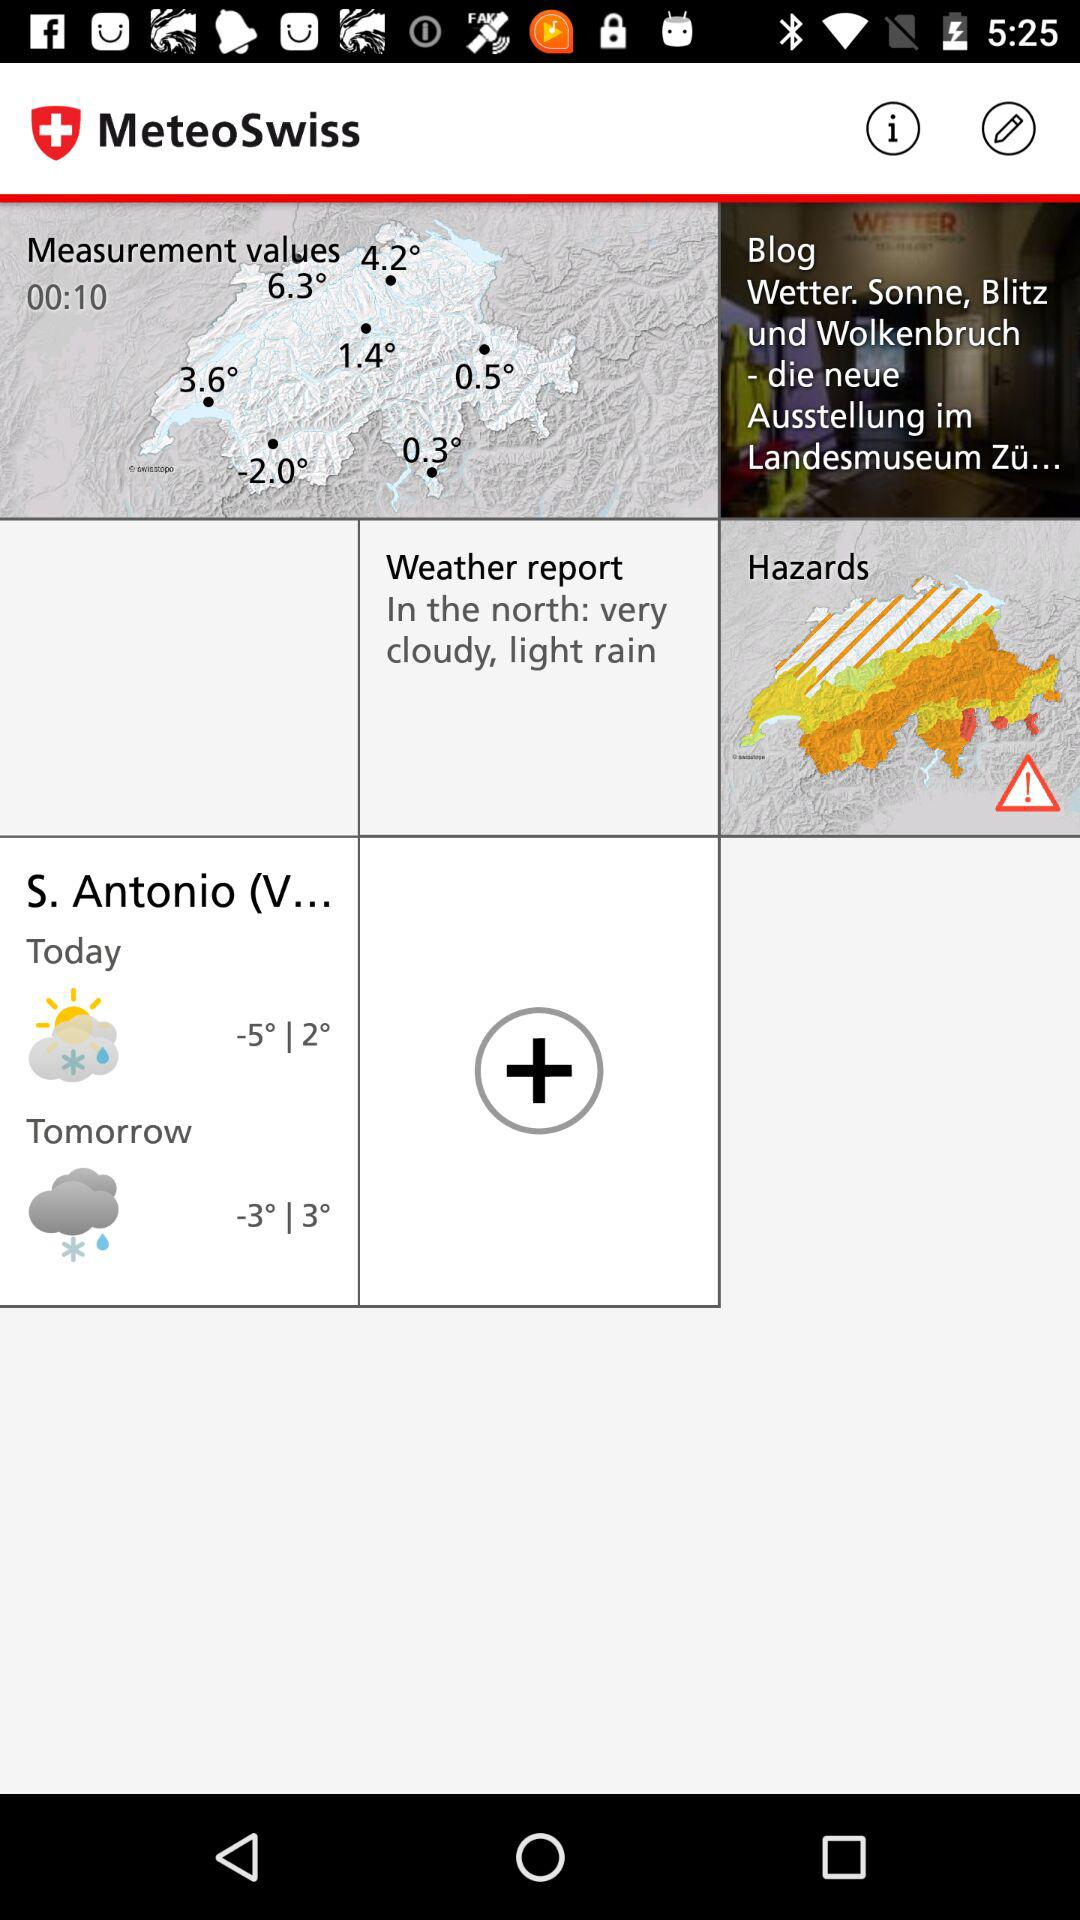What is the weather forecast for tomorrow? The weather forecast for tomorrow is sleet. 